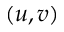<formula> <loc_0><loc_0><loc_500><loc_500>( u , v )</formula> 